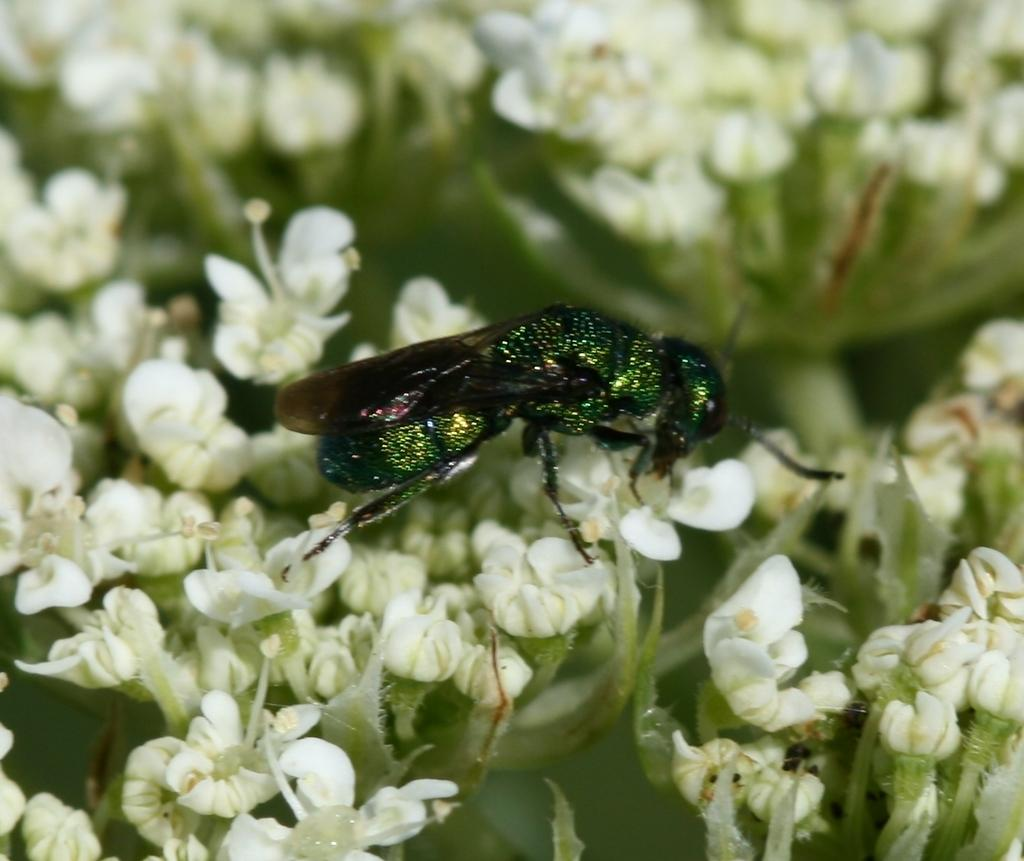What is present in the image? There is a fly in the image. What is the fly standing on? The fly is standing on white flowers. What type of hook is the fly using to hold onto the flowers? There is no hook present in the image; the fly is standing on the flowers. What is the minister doing in the image? There is no minister present in the image. 